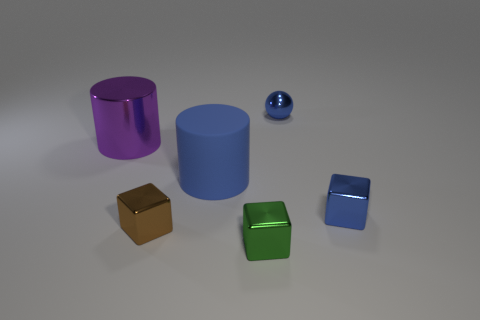Subtract all blue blocks. How many blocks are left? 2 Add 2 large cyan rubber balls. How many objects exist? 8 Subtract 1 cylinders. How many cylinders are left? 1 Subtract all blue cubes. How many cubes are left? 2 Add 5 big blue matte cylinders. How many big blue matte cylinders exist? 6 Subtract 1 blue cylinders. How many objects are left? 5 Subtract all cylinders. How many objects are left? 4 Subtract all gray cubes. Subtract all red cylinders. How many cubes are left? 3 Subtract all purple matte cubes. Subtract all small shiny cubes. How many objects are left? 3 Add 6 small blue spheres. How many small blue spheres are left? 7 